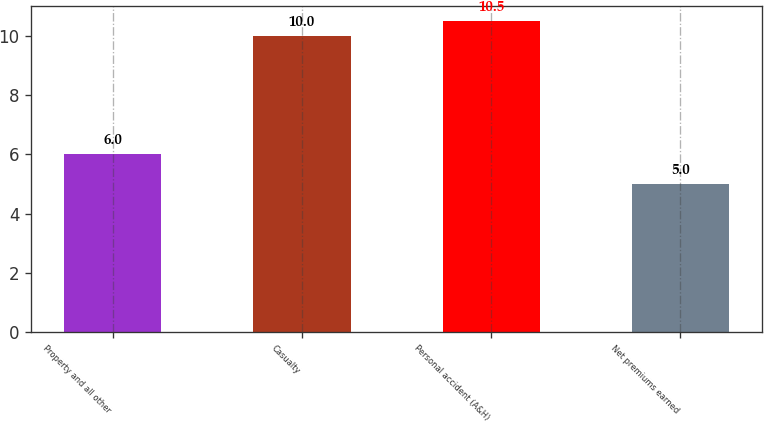Convert chart to OTSL. <chart><loc_0><loc_0><loc_500><loc_500><bar_chart><fcel>Property and all other<fcel>Casualty<fcel>Personal accident (A&H)<fcel>Net premiums earned<nl><fcel>6<fcel>10<fcel>10.5<fcel>5<nl></chart> 